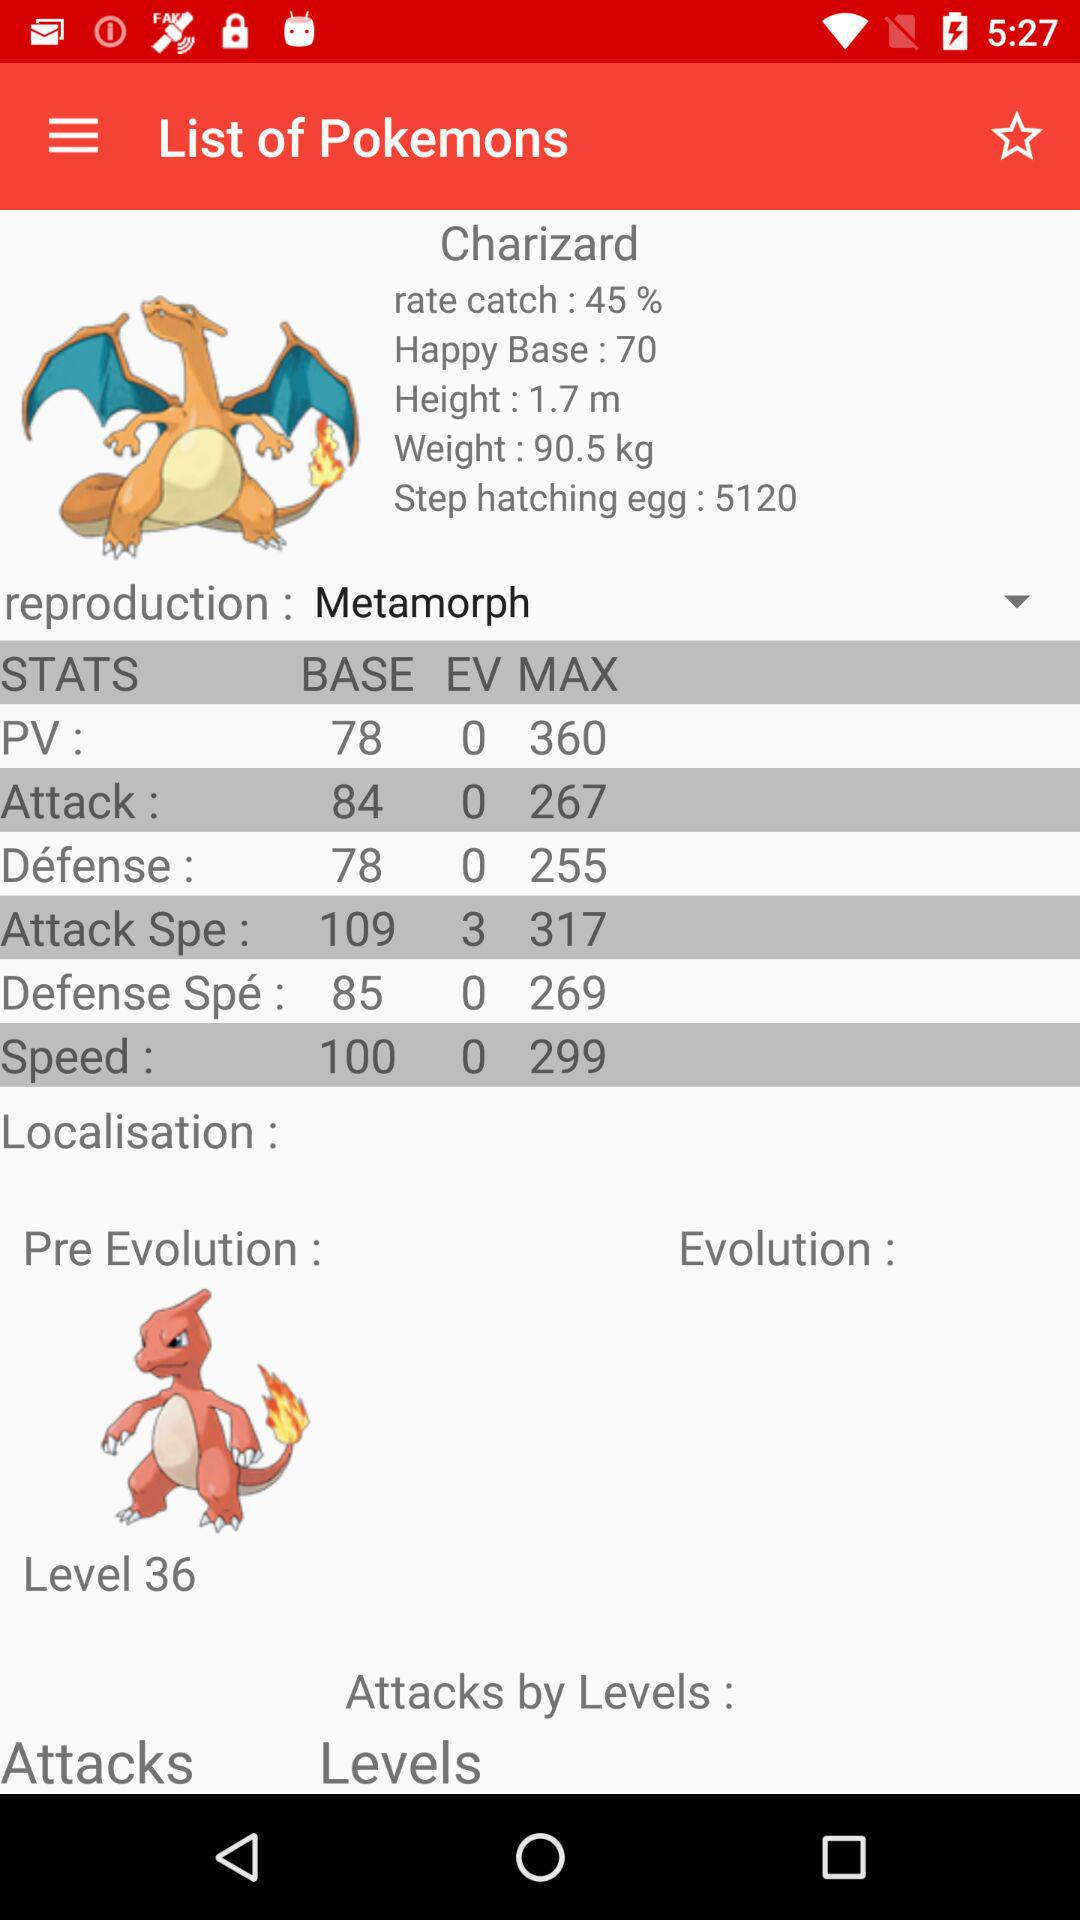What is the weight? The weight is 90.5 kg. 